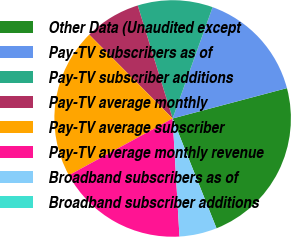Convert chart. <chart><loc_0><loc_0><loc_500><loc_500><pie_chart><fcel>Other Data (Unaudited except<fcel>Pay-TV subscribers as of<fcel>Pay-TV subscriber additions<fcel>Pay-TV average monthly<fcel>Pay-TV average subscriber<fcel>Pay-TV average monthly revenue<fcel>Broadband subscribers as of<fcel>Broadband subscriber additions<nl><fcel>23.08%<fcel>15.38%<fcel>10.26%<fcel>7.69%<fcel>20.51%<fcel>17.95%<fcel>5.13%<fcel>0.0%<nl></chart> 